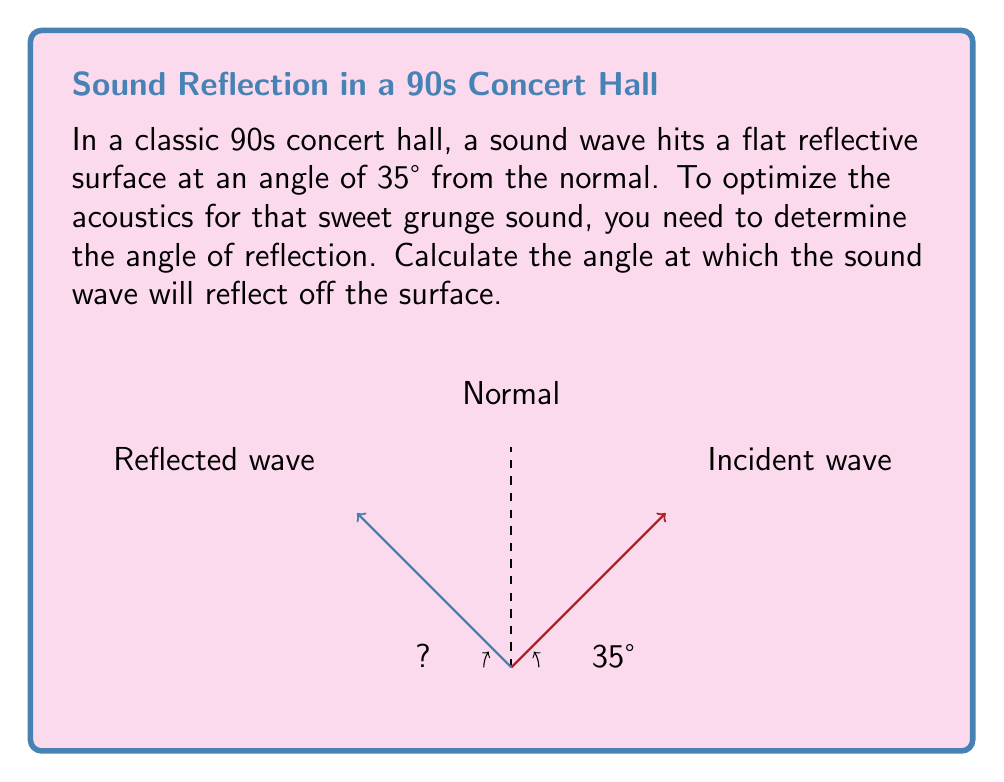What is the answer to this math problem? To solve this problem, we need to apply the law of reflection, which states that the angle of incidence is equal to the angle of reflection. Here's the step-by-step solution:

1. Identify the given information:
   - The angle of incidence is 35° from the normal.

2. Apply the law of reflection:
   $\text{Angle of incidence} = \text{Angle of reflection}$

3. Since the angle of incidence is 35°, the angle of reflection will also be 35°.

4. Note that this angle is measured from the normal line (the perpendicular to the reflective surface).

5. The reflected wave will form a 35° angle on the opposite side of the normal line.

This ensures that the sound waves in the 90s concert hall will be reflected symmetrically, maintaining the acoustic properties desired for the grunge music experience.
Answer: 35° 